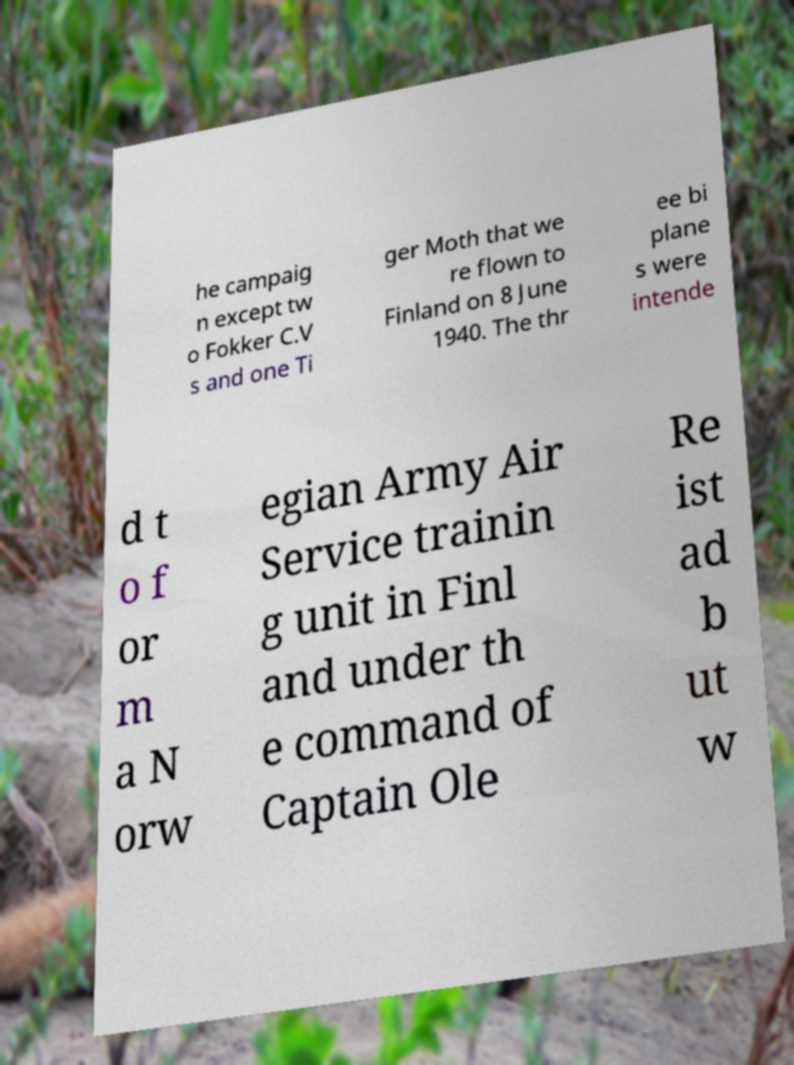Please read and relay the text visible in this image. What does it say? he campaig n except tw o Fokker C.V s and one Ti ger Moth that we re flown to Finland on 8 June 1940. The thr ee bi plane s were intende d t o f or m a N orw egian Army Air Service trainin g unit in Finl and under th e command of Captain Ole Re ist ad b ut w 